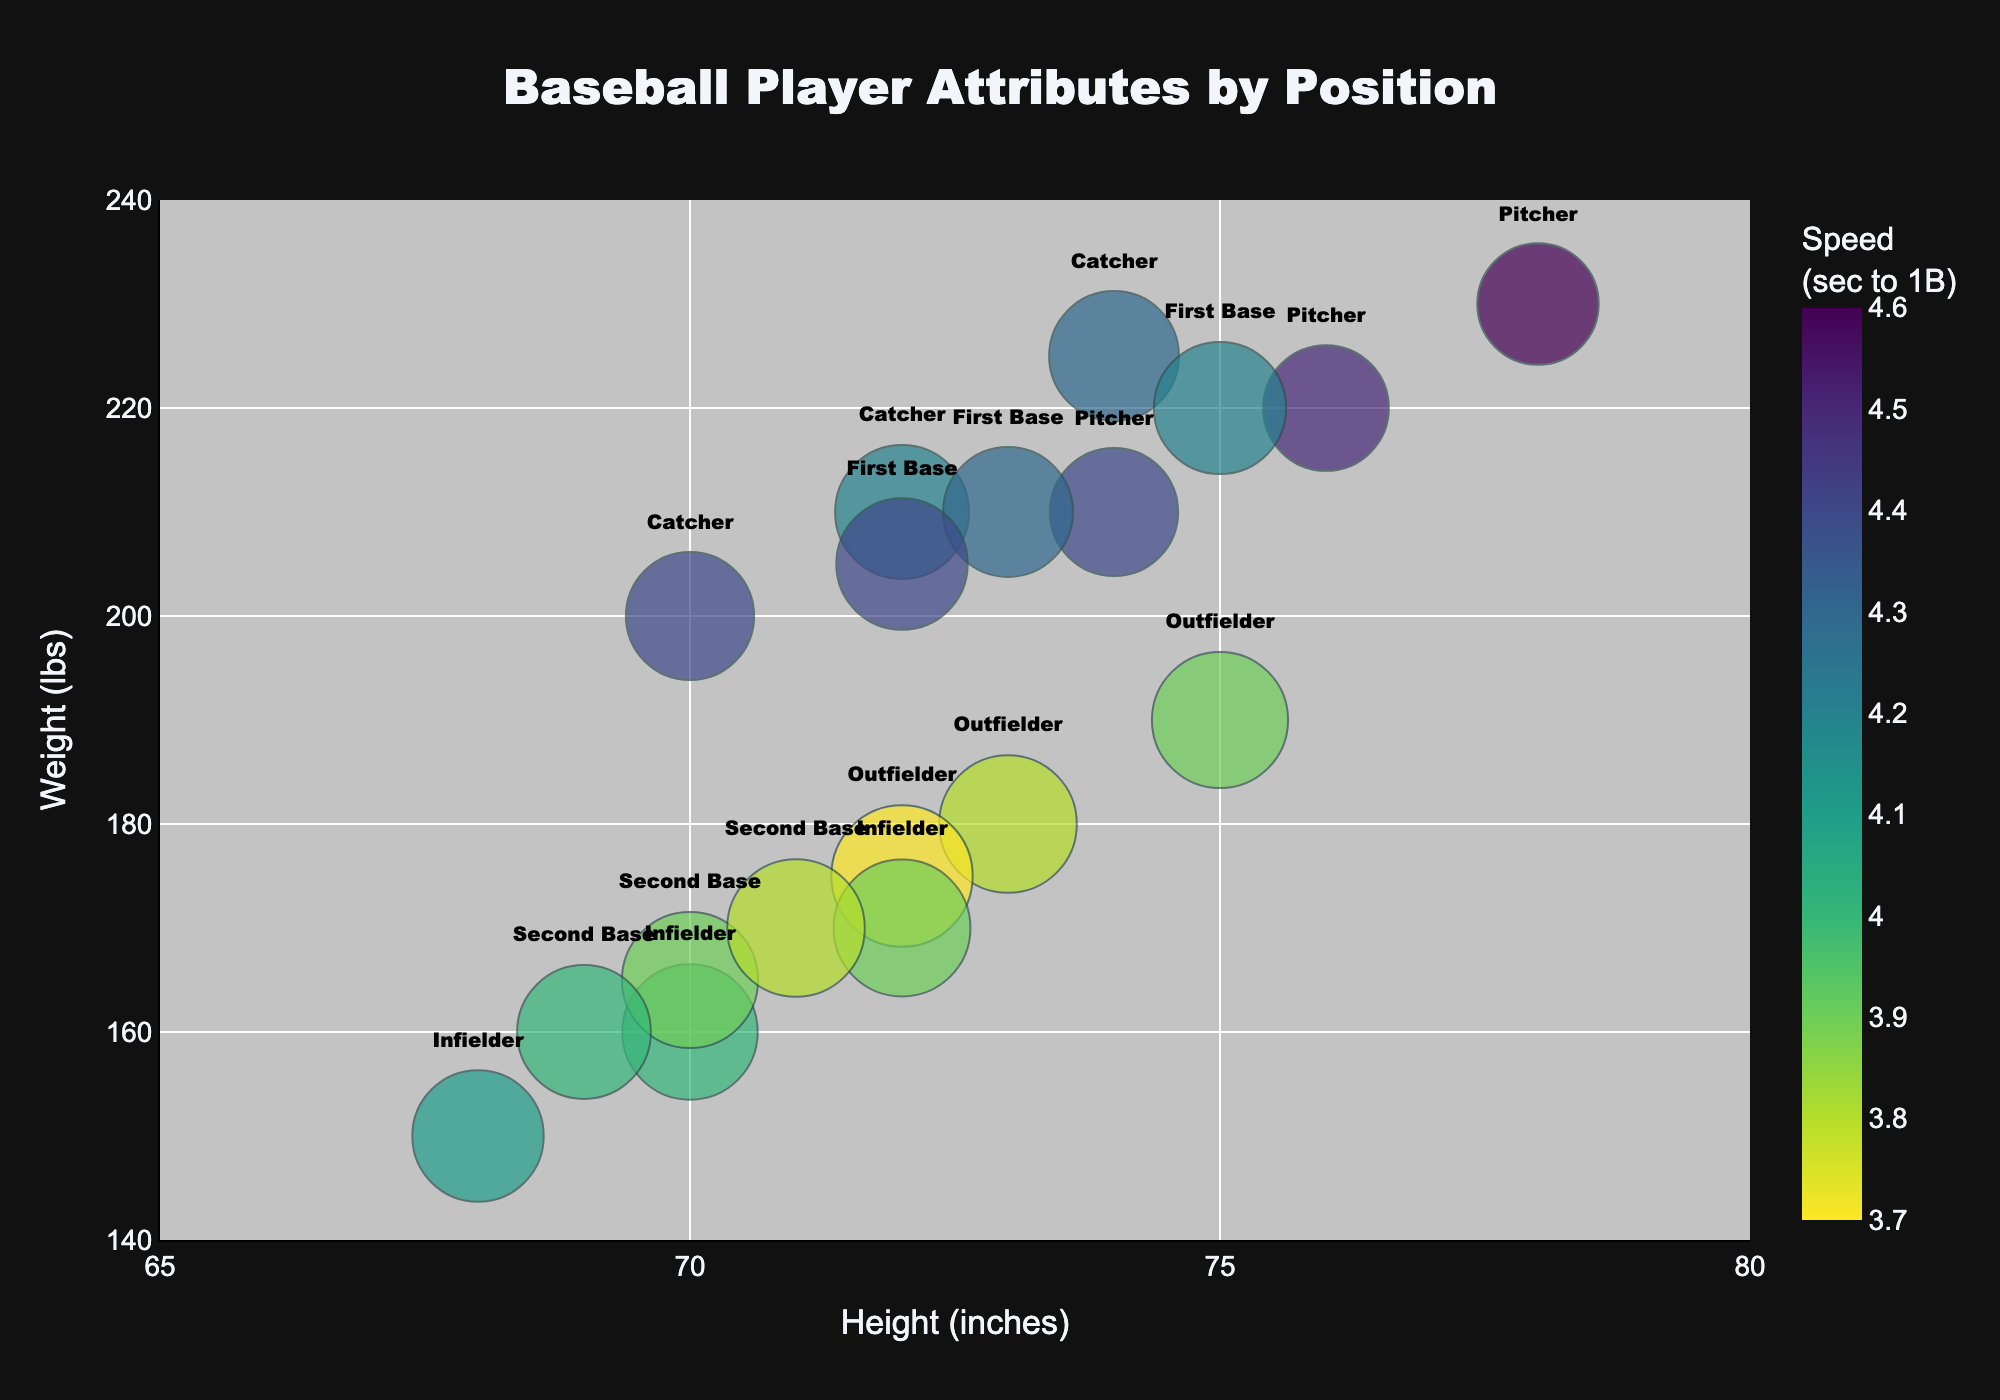what is the title of the figure? The title is positioned at the top center of the figure. The text is larger and bold, which makes it easy to see.
Answer: Baseball Player Attributes by Position what are the x-axis and y-axis labeled as? The x-axis is labeled "Height (inches)" and the y-axis is labeled "Weight (lbs)". These labels are near the axes and help in identifying the purpose of each axis.
Answer: Height (inches), Weight (lbs) which position has the highest success rate and what's their speed? By identifying the largest bubble in the chart and looking at the color indicating speed, outfielders show they have both the highest success rate and the blue color represents they have a speed of 3.7 seconds to 1B.
Answer: Outfielder, 3.7 sec how does the speed trend across different weight classes for outfielders? Observing the color gradient for outfielders will show that as the weight increases, the color shifts towards a higher value in seconds, indicating outfielders generally are slower with more weight.
Answer: Outfielders generally get slower as weight increases which position appears to have the heaviest players? Looking at the y-axis values where each position is plotted, pitchers consistently appear at higher weight values, indicating they are typically the heaviest.
Answer: Pitchers is there a correlation between height and success rate for infielders? Recognize the size of the bubbles representing success rate and the positioning of infielders along the x-axis. Taller infielders tend to have larger sized bubbles which indicates a higher success rate.
Answer: Taller infielders generally have higher success rates which position has the lightest players and how does their success rate compare? Observing the lower end of the y-axis where weights are plotted, infielders appear to be the lightest players and their success rates, represented by bubble size, are relatively high (larger bubbles).
Answer: Infielders, high success rate what position shows the greatest variability in height among players? The span of players' height for each position along the x-axis where the data points are spread out most. Pitchers show the greatest variability in this aspect.
Answer: Pitchers 